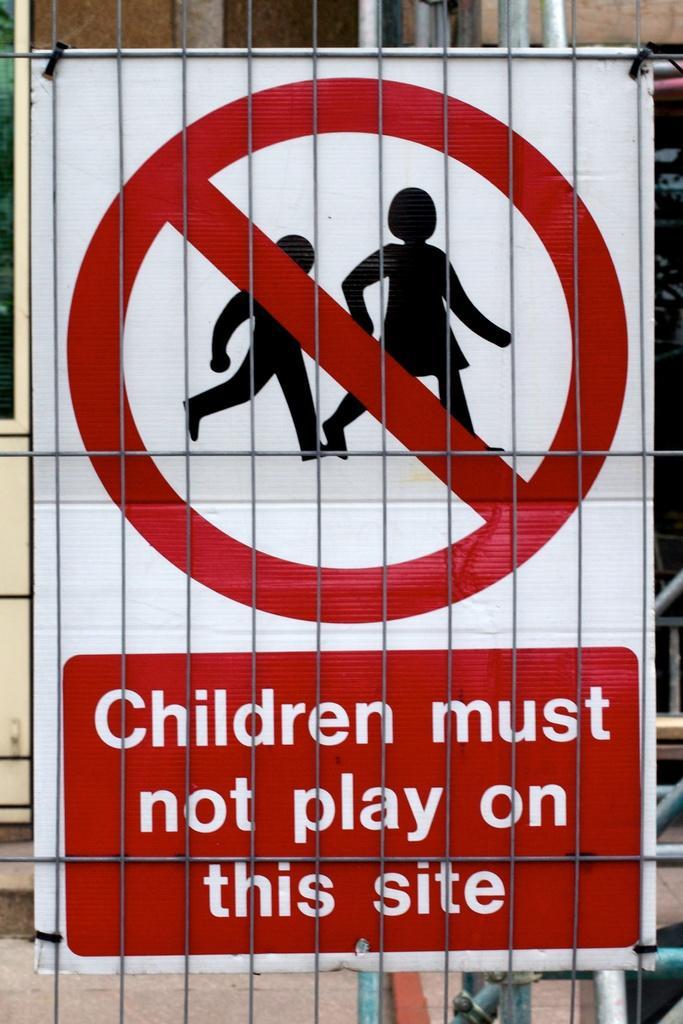Could you give a brief overview of what you see in this image? In this image there is a fencing truncated, there is a board on the fencing, there is text on the board, there are objects truncated towards the bottom of the image, there are objects truncated towards the top of the image, at the background of the image there is a wall truncated. 